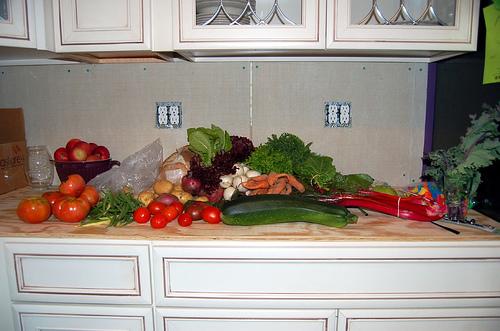What type of plant is pictured?
Answer briefly. Vegetable. How many sockets are shown?
Concise answer only. 4. How many cabinet handles can you see?
Give a very brief answer. 0. Are the vegetables fresh?
Be succinct. Yes. Is this a modern kitchen?
Write a very short answer. Yes. 